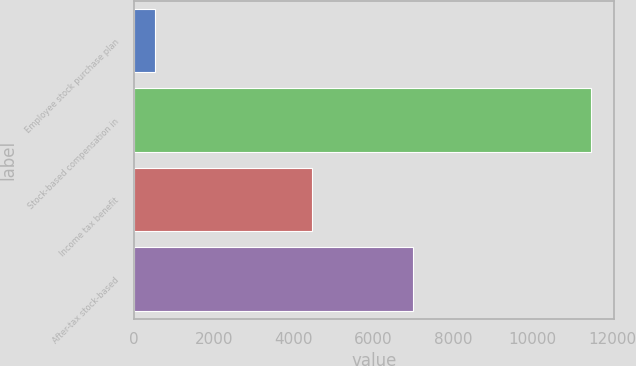<chart> <loc_0><loc_0><loc_500><loc_500><bar_chart><fcel>Employee stock purchase plan<fcel>Stock-based compensation in<fcel>Income tax benefit<fcel>After-tax stock-based<nl><fcel>530<fcel>11470<fcel>4473<fcel>6997<nl></chart> 